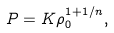<formula> <loc_0><loc_0><loc_500><loc_500>P = K \rho _ { 0 } ^ { 1 + 1 / n } ,</formula> 